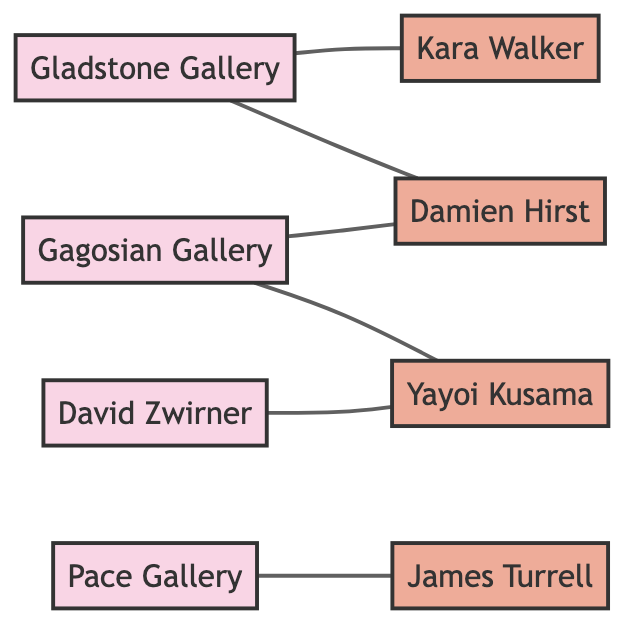What is the name of the artist represented by Gladstone Gallery? The diagram shows a direct connection between Gladstone Gallery (g1) and the artist Kara Walker (a1). Therefore, the answer is Kara Walker.
Answer: Kara Walker Which gallery represents Damien Hirst? The diagram indicates a connection from Gagosian Gallery (g2) to Damien Hirst (a2), indicating that Gagosian Gallery represents him.
Answer: Gagosian Gallery How many galleries are represented in this diagram? The diagram lists four galleries: Gladstone Gallery, Gagosian Gallery, David Zwirner, and Pace Gallery. Thus, the total count is four.
Answer: 4 Which artist is represented by both Gagosian Gallery and another gallery? The diagram shows that Yayoi Kusama (a3) is connected to both Gagosian Gallery (g2) and David Zwirner (g3), indicating representation by both.
Answer: Yayoi Kusama What is the total number of edges in the diagram? Counting the connections (edges) shown in the diagram, we have six edges connecting the galleries and artists.
Answer: 6 How many artists only have one gallery representing them? Looking at the connections, Kara Walker (a1), Damien Hirst (a2), and James Turrell (a4) each have only one gallery connected to them. Therefore, the count is three.
Answer: 3 Which artist does not have a direct connection to Pace Gallery? Analyzing the connections, both Kara Walker and Damien Hirst are directly connected to other galleries but not to Pace Gallery (g4). The answer therefore is James Turrell.
Answer: James Turrell What type of graph is represented by this diagram? The structure of the diagram indicates that it is an undirected graph, as there are connections without a specified direction between galleries and artists.
Answer: Undirected Graph What is the relationship between Gladstone Gallery and Damien Hirst? The diagram shows a direct connection from Gladstone Gallery (g1) to Damien Hirst (a2), indicating that the gallery represents the artist.
Answer: Represents 